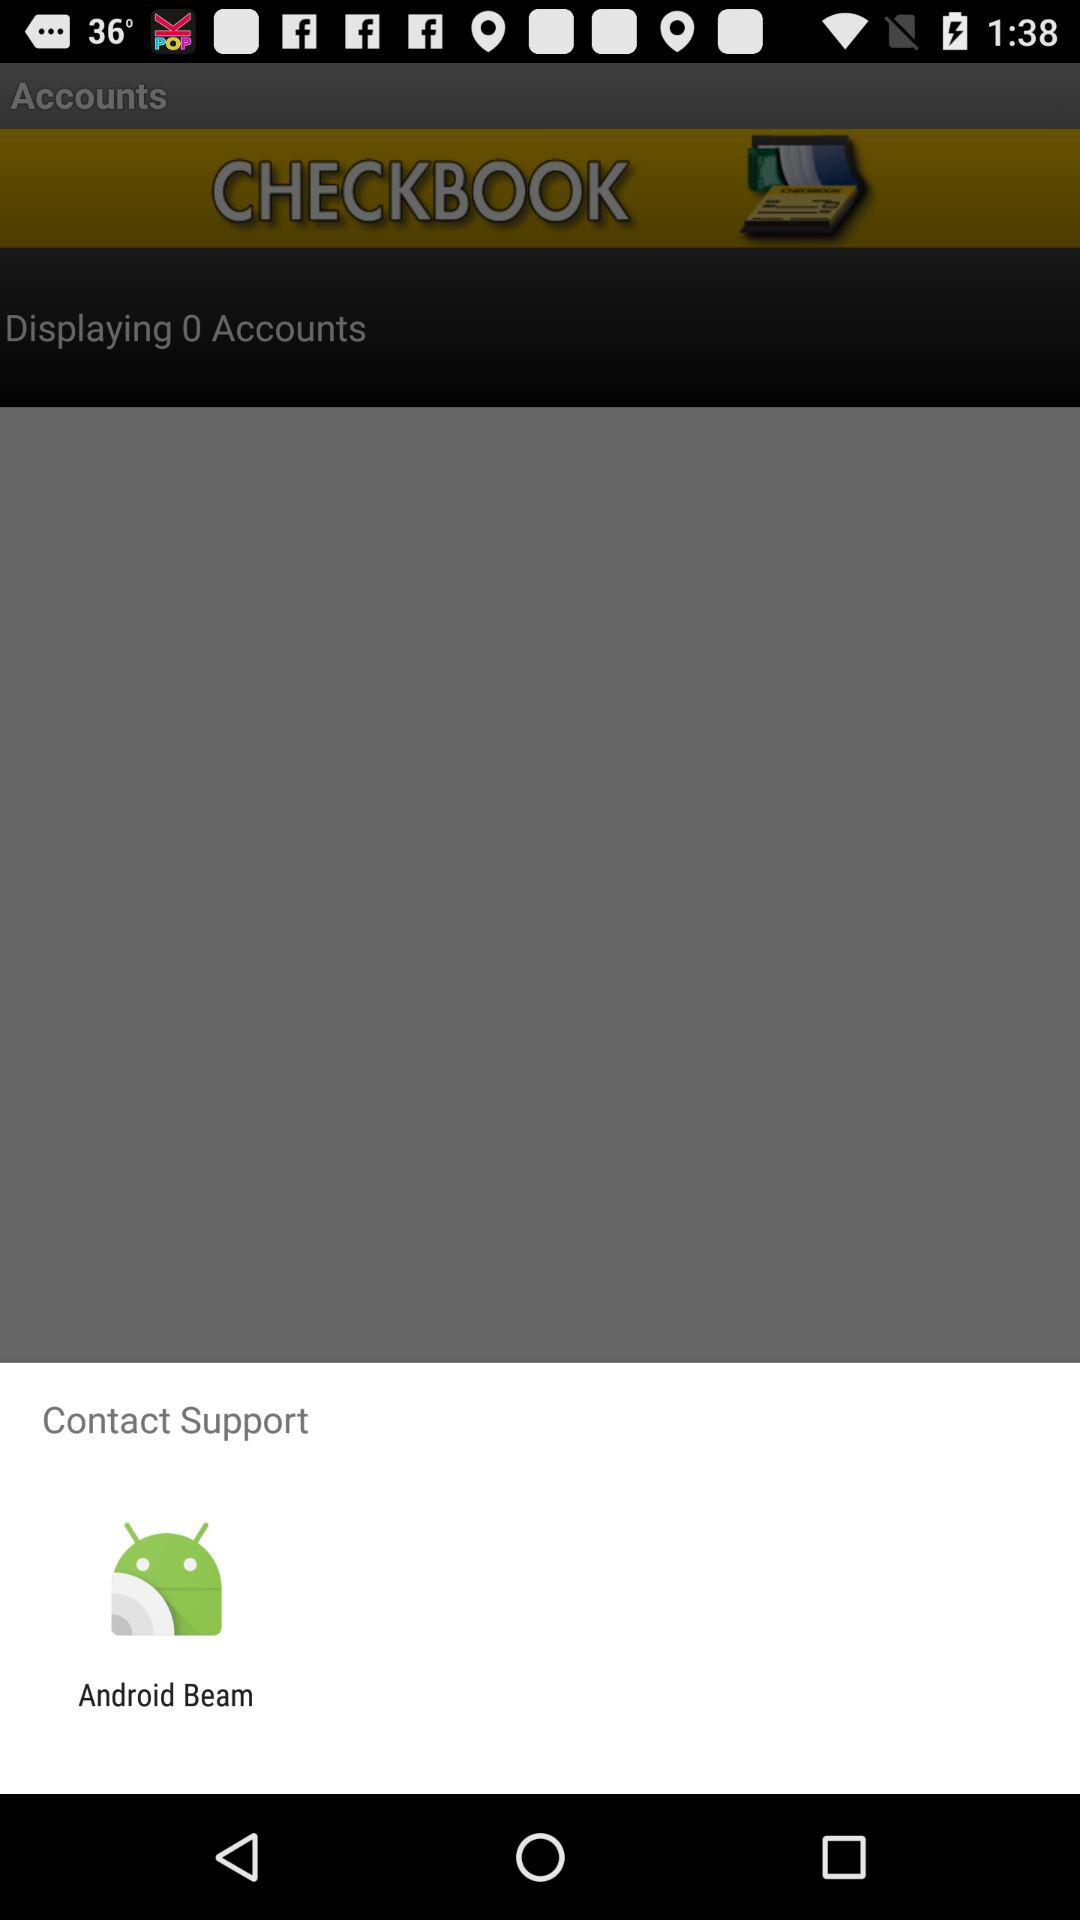What option can be used to contact support? The option that can be used to contact support is "Android Beam". 